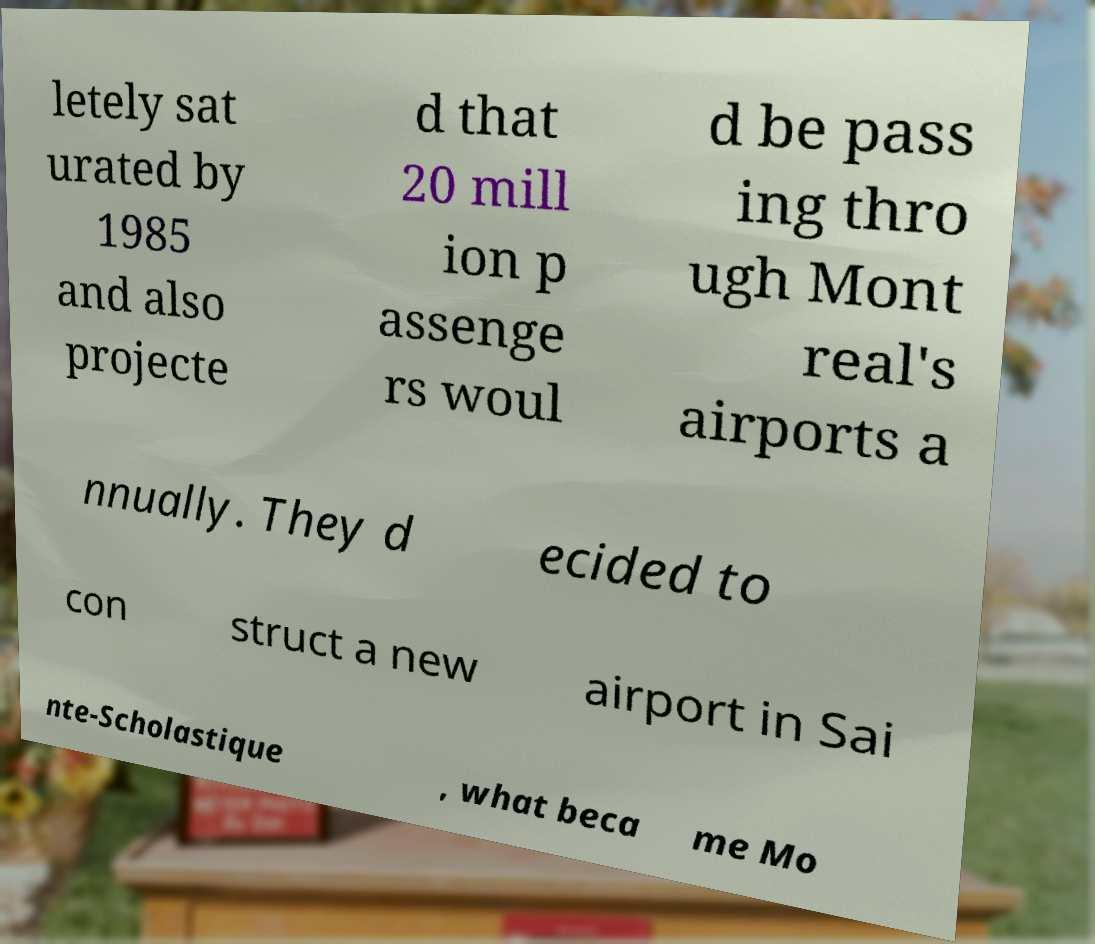There's text embedded in this image that I need extracted. Can you transcribe it verbatim? letely sat urated by 1985 and also projecte d that 20 mill ion p assenge rs woul d be pass ing thro ugh Mont real's airports a nnually. They d ecided to con struct a new airport in Sai nte-Scholastique , what beca me Mo 